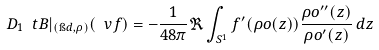Convert formula to latex. <formula><loc_0><loc_0><loc_500><loc_500>D _ { 1 } \ t B | _ { ( \i d , \rho ) } ( \ v f ) = - \frac { 1 } { 4 8 \pi } \Re \int _ { S ^ { 1 } } f ^ { \prime } ( \rho o ( z ) ) \frac { \rho o ^ { \prime \prime } ( z ) } { \rho o ^ { \prime } ( z ) } \, d z</formula> 